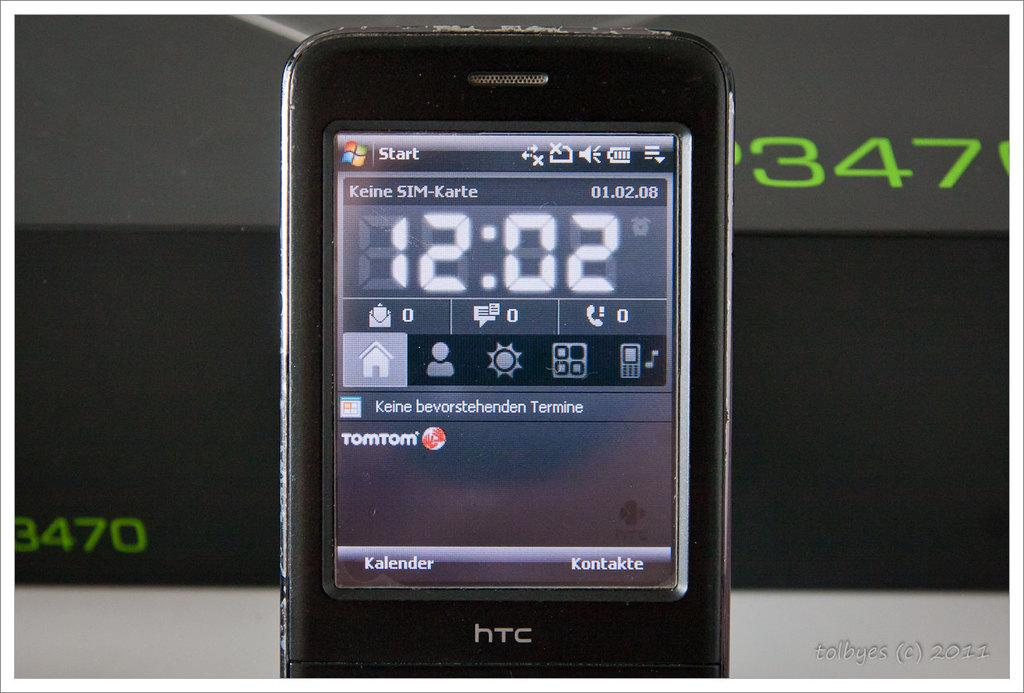<image>
Create a compact narrative representing the image presented. An HTC smart phone shows that the time is 12:02. 